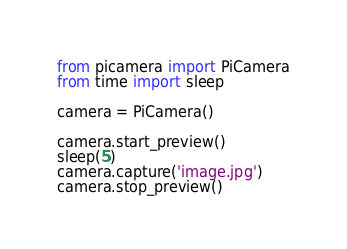<code> <loc_0><loc_0><loc_500><loc_500><_Python_>from picamera import PiCamera
from time import sleep

camera = PiCamera()

camera.start_preview()
sleep(5)
camera.capture('image.jpg')
camera.stop_preview()
</code> 